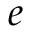<formula> <loc_0><loc_0><loc_500><loc_500>e</formula> 